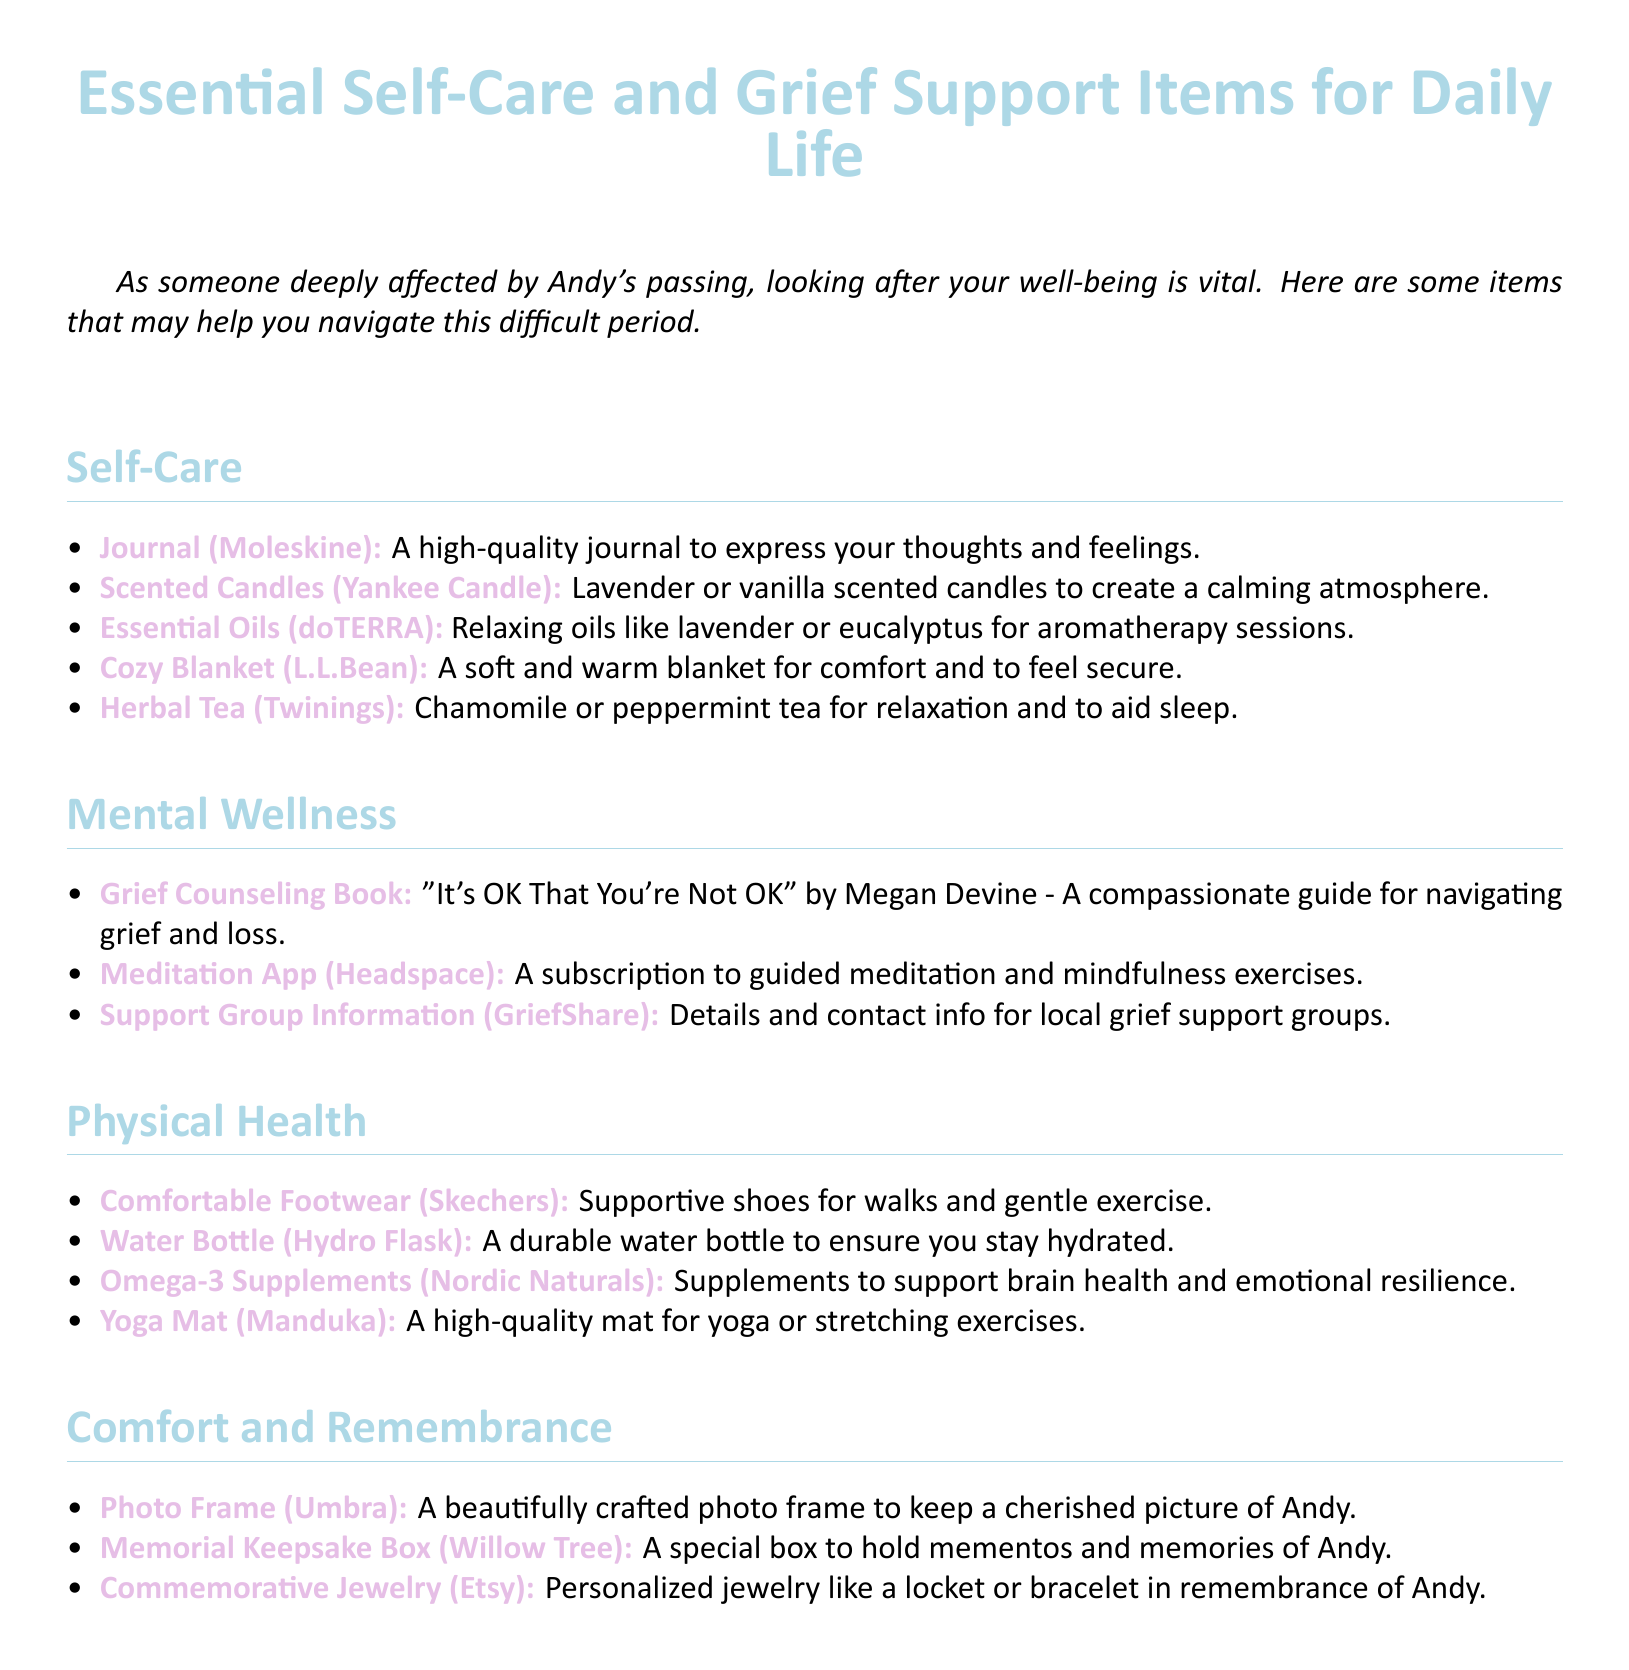What is the first item listed under Self-Care? The first item under Self-Care is specifically mentioned in the list.
Answer: Journal (Moleskine) What type of tea is suggested for relaxation? Herbal tea options are provided, specifying their purpose.
Answer: Chamomile What is the title of the grief counseling book mentioned? The document clearly states the title of the recommended book for grief.
Answer: "It's OK That You're Not OK" How many items are listed under Physical Health? The total number of items in the Physical Health section is counted to provide a precise answer.
Answer: Four What color are the scented candles suggested? The document specifies the colors associated with the candles for a calming effect.
Answer: Lavender or vanilla What type of app is recommended for mental wellness? The section describes the type of app for mental wellness that is suggested.
Answer: Meditation App (Headspace) What is suggested to hold mementos of Andy? The document indicates a specific type of item to keep memories.
Answer: Memorial Keepsake Box (Willow Tree) What brand of comfortable footwear is suggested? The document provides the brand name for the recommended comfortable footwear.
Answer: Skechers 